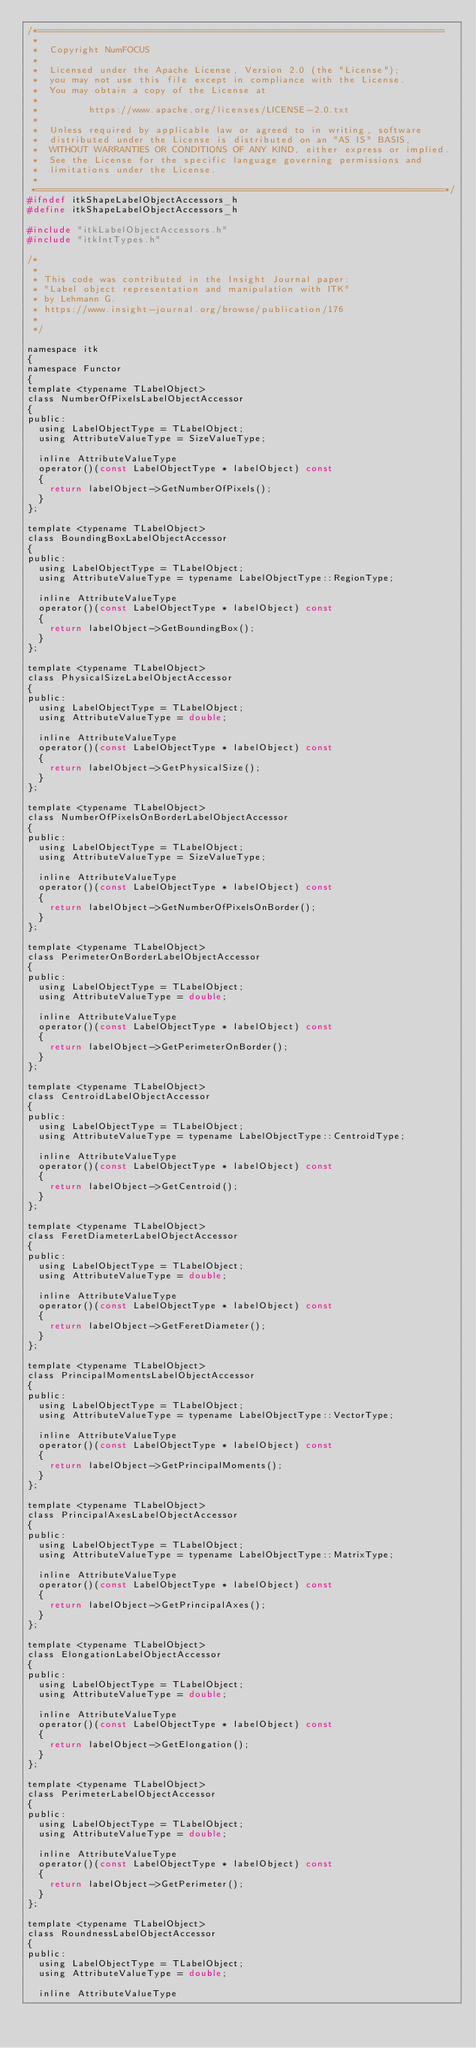<code> <loc_0><loc_0><loc_500><loc_500><_C_>/*=========================================================================
 *
 *  Copyright NumFOCUS
 *
 *  Licensed under the Apache License, Version 2.0 (the "License");
 *  you may not use this file except in compliance with the License.
 *  You may obtain a copy of the License at
 *
 *         https://www.apache.org/licenses/LICENSE-2.0.txt
 *
 *  Unless required by applicable law or agreed to in writing, software
 *  distributed under the License is distributed on an "AS IS" BASIS,
 *  WITHOUT WARRANTIES OR CONDITIONS OF ANY KIND, either express or implied.
 *  See the License for the specific language governing permissions and
 *  limitations under the License.
 *
 *=========================================================================*/
#ifndef itkShapeLabelObjectAccessors_h
#define itkShapeLabelObjectAccessors_h

#include "itkLabelObjectAccessors.h"
#include "itkIntTypes.h"

/*
 *
 * This code was contributed in the Insight Journal paper:
 * "Label object representation and manipulation with ITK"
 * by Lehmann G.
 * https://www.insight-journal.org/browse/publication/176
 *
 */

namespace itk
{
namespace Functor
{
template <typename TLabelObject>
class NumberOfPixelsLabelObjectAccessor
{
public:
  using LabelObjectType = TLabelObject;
  using AttributeValueType = SizeValueType;

  inline AttributeValueType
  operator()(const LabelObjectType * labelObject) const
  {
    return labelObject->GetNumberOfPixels();
  }
};

template <typename TLabelObject>
class BoundingBoxLabelObjectAccessor
{
public:
  using LabelObjectType = TLabelObject;
  using AttributeValueType = typename LabelObjectType::RegionType;

  inline AttributeValueType
  operator()(const LabelObjectType * labelObject) const
  {
    return labelObject->GetBoundingBox();
  }
};

template <typename TLabelObject>
class PhysicalSizeLabelObjectAccessor
{
public:
  using LabelObjectType = TLabelObject;
  using AttributeValueType = double;

  inline AttributeValueType
  operator()(const LabelObjectType * labelObject) const
  {
    return labelObject->GetPhysicalSize();
  }
};

template <typename TLabelObject>
class NumberOfPixelsOnBorderLabelObjectAccessor
{
public:
  using LabelObjectType = TLabelObject;
  using AttributeValueType = SizeValueType;

  inline AttributeValueType
  operator()(const LabelObjectType * labelObject) const
  {
    return labelObject->GetNumberOfPixelsOnBorder();
  }
};

template <typename TLabelObject>
class PerimeterOnBorderLabelObjectAccessor
{
public:
  using LabelObjectType = TLabelObject;
  using AttributeValueType = double;

  inline AttributeValueType
  operator()(const LabelObjectType * labelObject) const
  {
    return labelObject->GetPerimeterOnBorder();
  }
};

template <typename TLabelObject>
class CentroidLabelObjectAccessor
{
public:
  using LabelObjectType = TLabelObject;
  using AttributeValueType = typename LabelObjectType::CentroidType;

  inline AttributeValueType
  operator()(const LabelObjectType * labelObject) const
  {
    return labelObject->GetCentroid();
  }
};

template <typename TLabelObject>
class FeretDiameterLabelObjectAccessor
{
public:
  using LabelObjectType = TLabelObject;
  using AttributeValueType = double;

  inline AttributeValueType
  operator()(const LabelObjectType * labelObject) const
  {
    return labelObject->GetFeretDiameter();
  }
};

template <typename TLabelObject>
class PrincipalMomentsLabelObjectAccessor
{
public:
  using LabelObjectType = TLabelObject;
  using AttributeValueType = typename LabelObjectType::VectorType;

  inline AttributeValueType
  operator()(const LabelObjectType * labelObject) const
  {
    return labelObject->GetPrincipalMoments();
  }
};

template <typename TLabelObject>
class PrincipalAxesLabelObjectAccessor
{
public:
  using LabelObjectType = TLabelObject;
  using AttributeValueType = typename LabelObjectType::MatrixType;

  inline AttributeValueType
  operator()(const LabelObjectType * labelObject) const
  {
    return labelObject->GetPrincipalAxes();
  }
};

template <typename TLabelObject>
class ElongationLabelObjectAccessor
{
public:
  using LabelObjectType = TLabelObject;
  using AttributeValueType = double;

  inline AttributeValueType
  operator()(const LabelObjectType * labelObject) const
  {
    return labelObject->GetElongation();
  }
};

template <typename TLabelObject>
class PerimeterLabelObjectAccessor
{
public:
  using LabelObjectType = TLabelObject;
  using AttributeValueType = double;

  inline AttributeValueType
  operator()(const LabelObjectType * labelObject) const
  {
    return labelObject->GetPerimeter();
  }
};

template <typename TLabelObject>
class RoundnessLabelObjectAccessor
{
public:
  using LabelObjectType = TLabelObject;
  using AttributeValueType = double;

  inline AttributeValueType</code> 